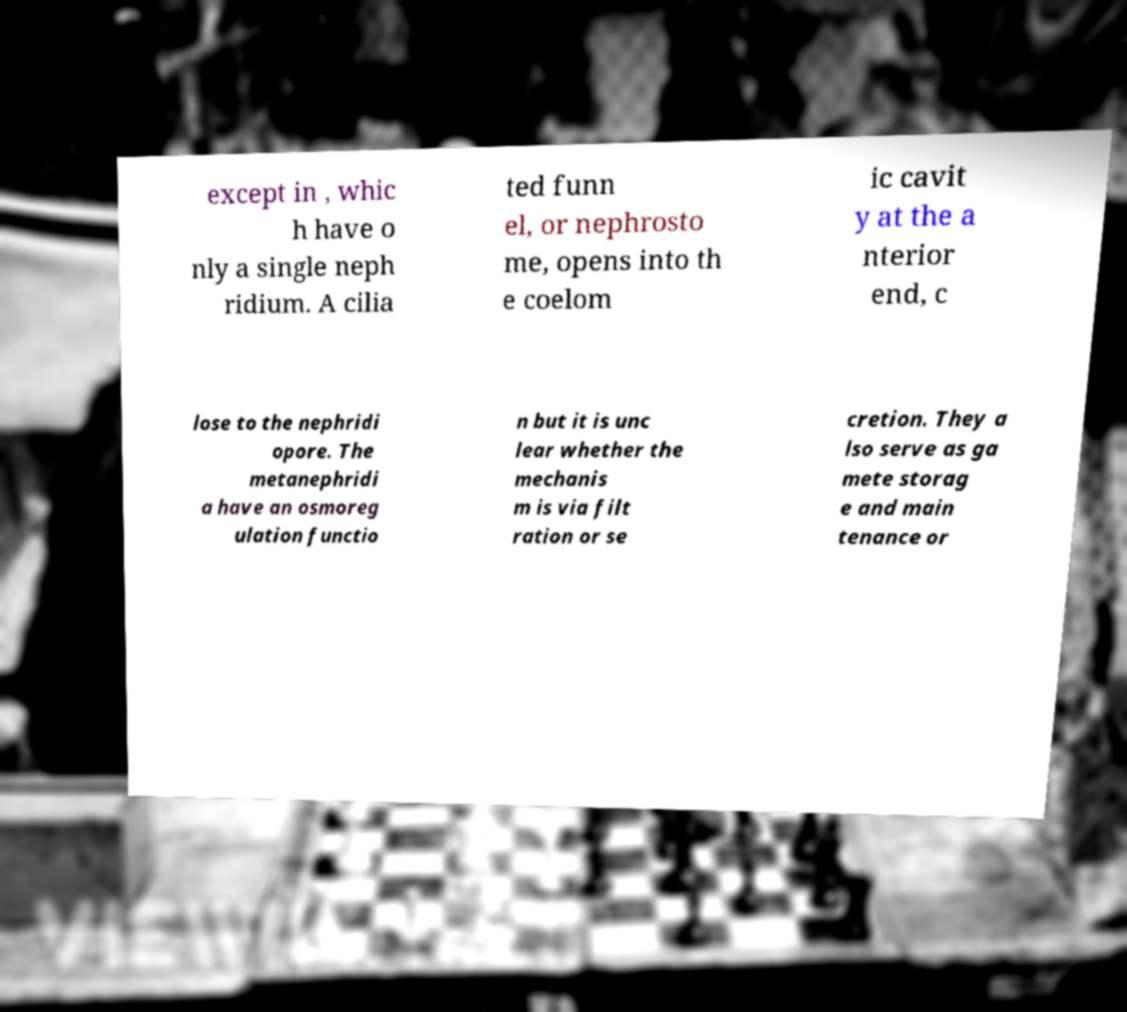Can you accurately transcribe the text from the provided image for me? except in , whic h have o nly a single neph ridium. A cilia ted funn el, or nephrosto me, opens into th e coelom ic cavit y at the a nterior end, c lose to the nephridi opore. The metanephridi a have an osmoreg ulation functio n but it is unc lear whether the mechanis m is via filt ration or se cretion. They a lso serve as ga mete storag e and main tenance or 